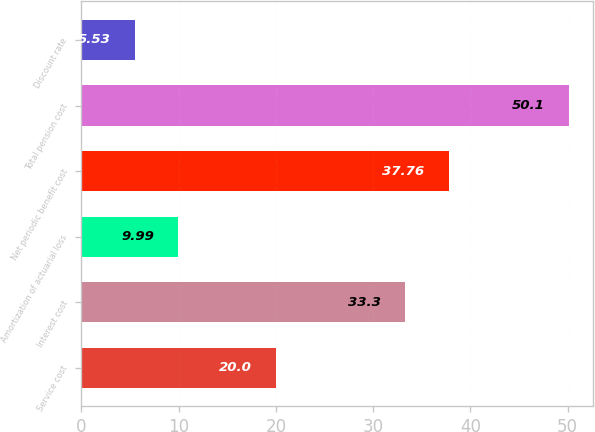Convert chart to OTSL. <chart><loc_0><loc_0><loc_500><loc_500><bar_chart><fcel>Service cost<fcel>Interest cost<fcel>Amortization of actuarial loss<fcel>Net periodic benefit cost<fcel>Total pension cost<fcel>Discount rate<nl><fcel>20<fcel>33.3<fcel>9.99<fcel>37.76<fcel>50.1<fcel>5.53<nl></chart> 